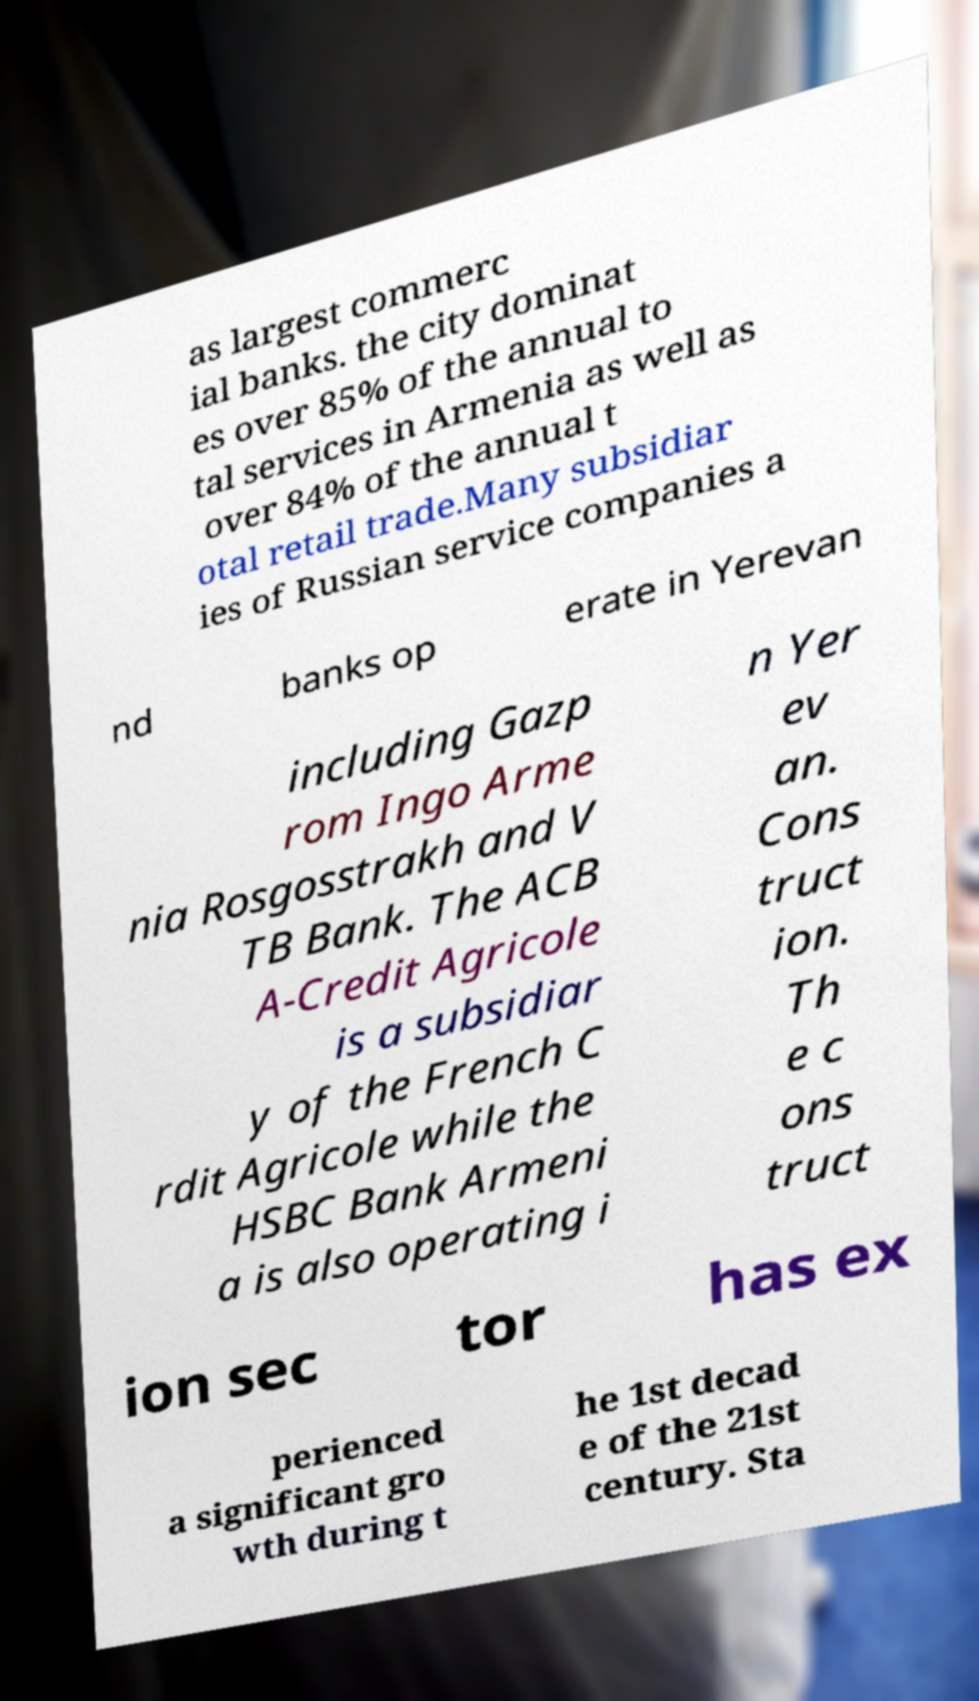Could you extract and type out the text from this image? as largest commerc ial banks. the city dominat es over 85% of the annual to tal services in Armenia as well as over 84% of the annual t otal retail trade.Many subsidiar ies of Russian service companies a nd banks op erate in Yerevan including Gazp rom Ingo Arme nia Rosgosstrakh and V TB Bank. The ACB A-Credit Agricole is a subsidiar y of the French C rdit Agricole while the HSBC Bank Armeni a is also operating i n Yer ev an. Cons truct ion. Th e c ons truct ion sec tor has ex perienced a significant gro wth during t he 1st decad e of the 21st century. Sta 